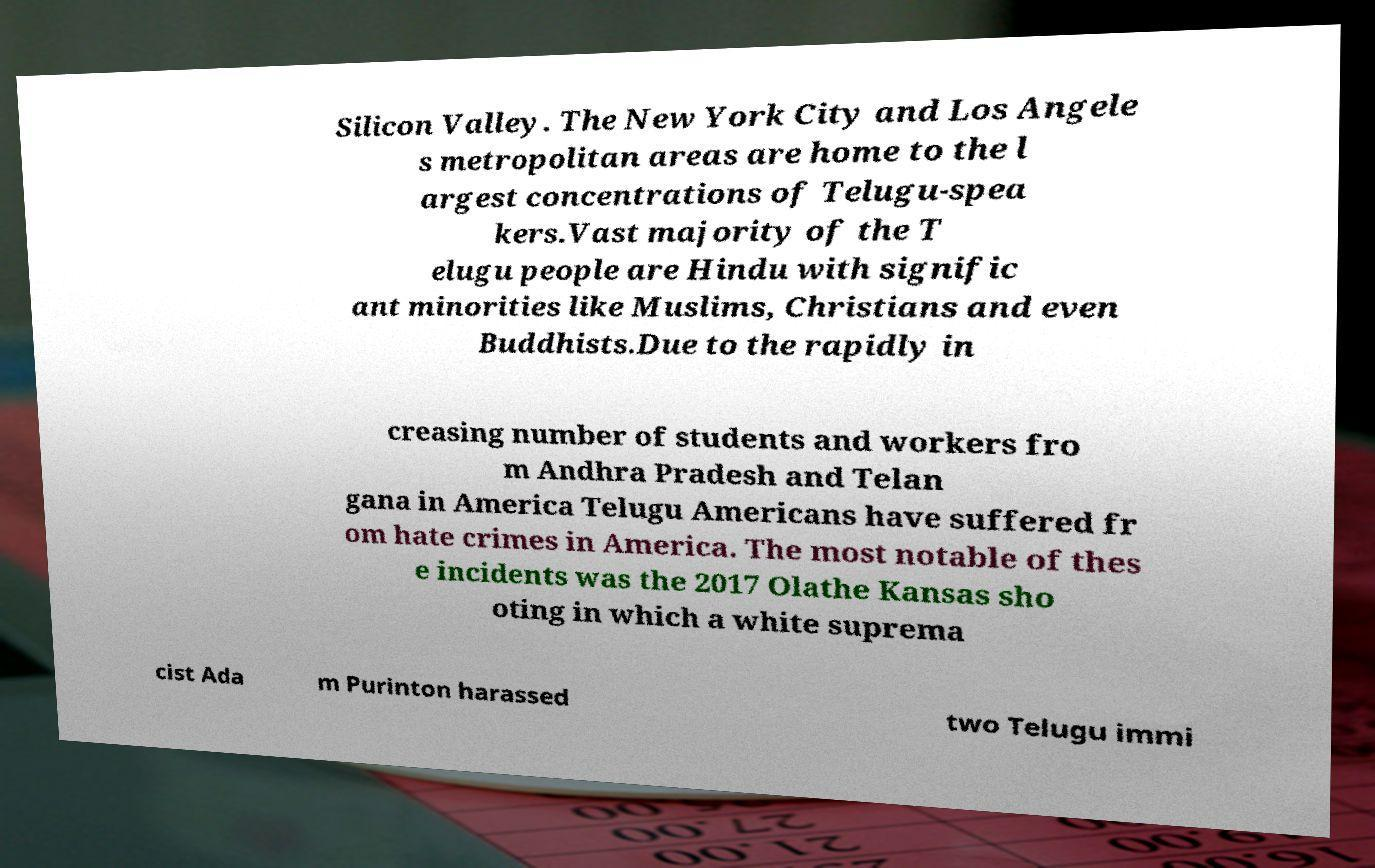Can you read and provide the text displayed in the image?This photo seems to have some interesting text. Can you extract and type it out for me? Silicon Valley. The New York City and Los Angele s metropolitan areas are home to the l argest concentrations of Telugu-spea kers.Vast majority of the T elugu people are Hindu with signific ant minorities like Muslims, Christians and even Buddhists.Due to the rapidly in creasing number of students and workers fro m Andhra Pradesh and Telan gana in America Telugu Americans have suffered fr om hate crimes in America. The most notable of thes e incidents was the 2017 Olathe Kansas sho oting in which a white suprema cist Ada m Purinton harassed two Telugu immi 